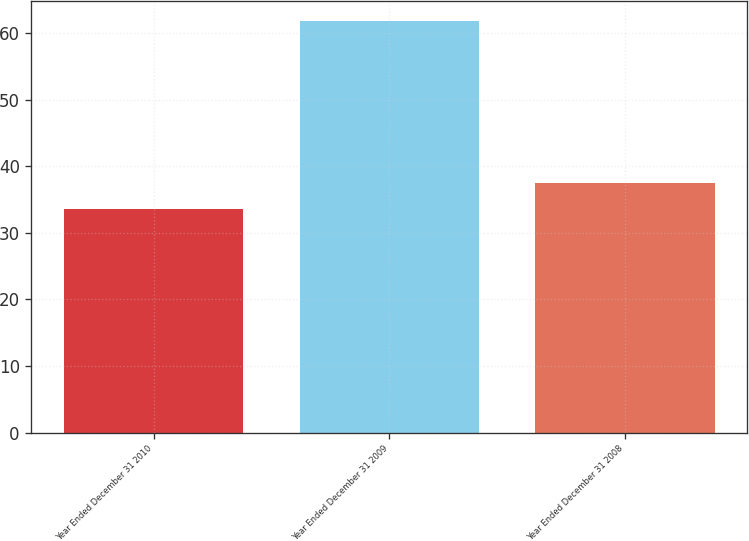<chart> <loc_0><loc_0><loc_500><loc_500><bar_chart><fcel>Year Ended December 31 2010<fcel>Year Ended December 31 2009<fcel>Year Ended December 31 2008<nl><fcel>33.6<fcel>61.8<fcel>37.5<nl></chart> 